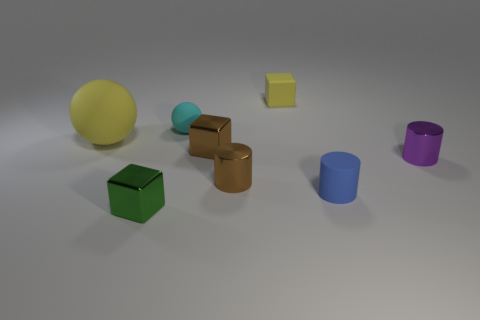Is the number of big matte objects in front of the green cube less than the number of things?
Provide a succinct answer. Yes. The tiny matte thing that is both behind the tiny purple shiny cylinder and in front of the small yellow block is what color?
Make the answer very short. Cyan. How many other things are the same shape as the green shiny thing?
Your response must be concise. 2. Is the number of yellow balls that are behind the matte block less than the number of large yellow objects that are in front of the big yellow matte thing?
Your response must be concise. No. Is the material of the tiny purple object the same as the thing that is in front of the tiny rubber cylinder?
Your response must be concise. Yes. Are there any other things that have the same material as the blue thing?
Provide a succinct answer. Yes. Is the number of small gray spheres greater than the number of small yellow objects?
Give a very brief answer. No. The small brown metallic thing behind the metallic object right of the cylinder that is left of the tiny yellow cube is what shape?
Keep it short and to the point. Cube. Does the tiny cylinder on the left side of the tiny rubber cube have the same material as the sphere that is to the left of the green thing?
Offer a very short reply. No. There is a tiny purple object that is the same material as the tiny green block; what shape is it?
Keep it short and to the point. Cylinder. 